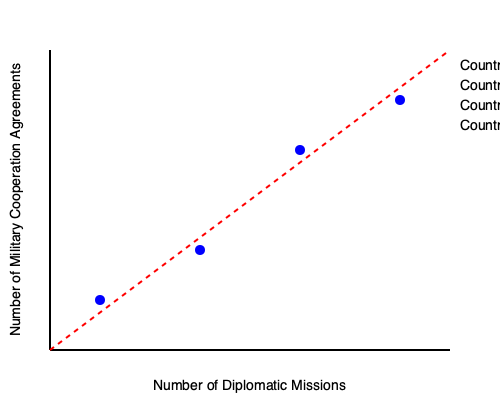Based on the chart showing the correlation between diplomatic missions and military cooperation agreements for four countries, which country demonstrates the strongest positive relationship between these two variables? To determine which country demonstrates the strongest positive relationship between diplomatic missions and military cooperation agreements, we need to analyze the position of each data point relative to the trend line:

1. The red dashed line represents the general trend of the relationship between diplomatic missions and military cooperation agreements.

2. A stronger positive relationship is indicated by a data point's proximity to this trend line and its position towards the upper-right of the chart.

3. Analyzing each country's position:
   - Country A (bottom-left point): Low number of diplomatic missions and military cooperation agreements.
   - Country B (second from bottom-left): Slightly higher in both variables compared to Country A.
   - Country C (third from bottom-left): Higher in both variables compared to Countries A and B.
   - Country D (top-right point): Highest number of diplomatic missions and military cooperation agreements.

4. Country D's data point is closest to the trend line and positioned furthest towards the upper-right corner of the chart.

5. This indicates that Country D shows the strongest positive relationship between diplomatic missions and military cooperation agreements.
Answer: Country D 